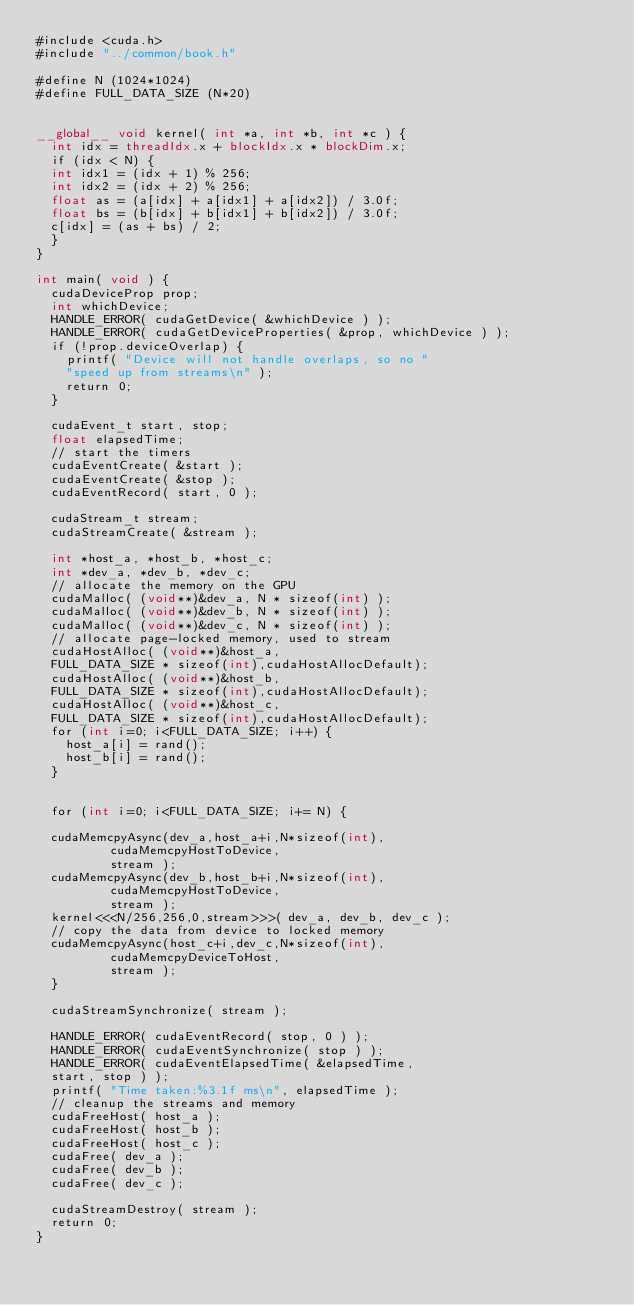<code> <loc_0><loc_0><loc_500><loc_500><_Cuda_>#include <cuda.h>
#include "../common/book.h"

#define N (1024*1024)
#define FULL_DATA_SIZE (N*20)


__global__ void kernel( int *a, int *b, int *c ) {
	int idx = threadIdx.x + blockIdx.x * blockDim.x;
	if (idx < N) {
	int idx1 = (idx + 1) % 256;
	int idx2 = (idx + 2) % 256;
	float as = (a[idx] + a[idx1] + a[idx2]) / 3.0f;
	float bs = (b[idx] + b[idx1] + b[idx2]) / 3.0f;
	c[idx] = (as + bs) / 2;
	}
}

int main( void ) {
	cudaDeviceProp prop;
	int whichDevice;
	HANDLE_ERROR( cudaGetDevice( &whichDevice ) );
	HANDLE_ERROR( cudaGetDeviceProperties( &prop, whichDevice ) );
	if (!prop.deviceOverlap) {
		printf( "Device will not handle overlaps, so no "
		"speed up from streams\n" );
		return 0;
	}

	cudaEvent_t start, stop;
	float elapsedTime;
	// start the timers
	cudaEventCreate( &start );
	cudaEventCreate( &stop );
	cudaEventRecord( start, 0 );

	cudaStream_t stream;
	cudaStreamCreate( &stream );

	int *host_a, *host_b, *host_c;
	int *dev_a, *dev_b, *dev_c;
	// allocate the memory on the GPU
	cudaMalloc( (void**)&dev_a, N * sizeof(int) );
	cudaMalloc( (void**)&dev_b, N * sizeof(int) );
	cudaMalloc( (void**)&dev_c, N * sizeof(int) );
	// allocate page-locked memory, used to stream
	cudaHostAlloc( (void**)&host_a,
	FULL_DATA_SIZE * sizeof(int),cudaHostAllocDefault);
	cudaHostAlloc( (void**)&host_b,
	FULL_DATA_SIZE * sizeof(int),cudaHostAllocDefault);
	cudaHostAlloc( (void**)&host_c,
	FULL_DATA_SIZE * sizeof(int),cudaHostAllocDefault);
	for (int i=0; i<FULL_DATA_SIZE; i++) {
		host_a[i] = rand();
		host_b[i] = rand();
	}


	for (int i=0; i<FULL_DATA_SIZE; i+= N) {

	cudaMemcpyAsync(dev_a,host_a+i,N*sizeof(int),
					cudaMemcpyHostToDevice,
					stream );
	cudaMemcpyAsync(dev_b,host_b+i,N*sizeof(int),
					cudaMemcpyHostToDevice,
					stream );
	kernel<<<N/256,256,0,stream>>>( dev_a, dev_b, dev_c );
	// copy the data from device to locked memory
	cudaMemcpyAsync(host_c+i,dev_c,N*sizeof(int),
					cudaMemcpyDeviceToHost,
					stream );
	}

	cudaStreamSynchronize( stream );

	HANDLE_ERROR( cudaEventRecord( stop, 0 ) );
	HANDLE_ERROR( cudaEventSynchronize( stop ) );
	HANDLE_ERROR( cudaEventElapsedTime( &elapsedTime,
	start, stop ) );
	printf( "Time taken:%3.1f ms\n", elapsedTime );
	// cleanup the streams and memory
	cudaFreeHost( host_a );
	cudaFreeHost( host_b );
	cudaFreeHost( host_c );
	cudaFree( dev_a );
	cudaFree( dev_b );
	cudaFree( dev_c );

	cudaStreamDestroy( stream );
	return 0;
}
</code> 